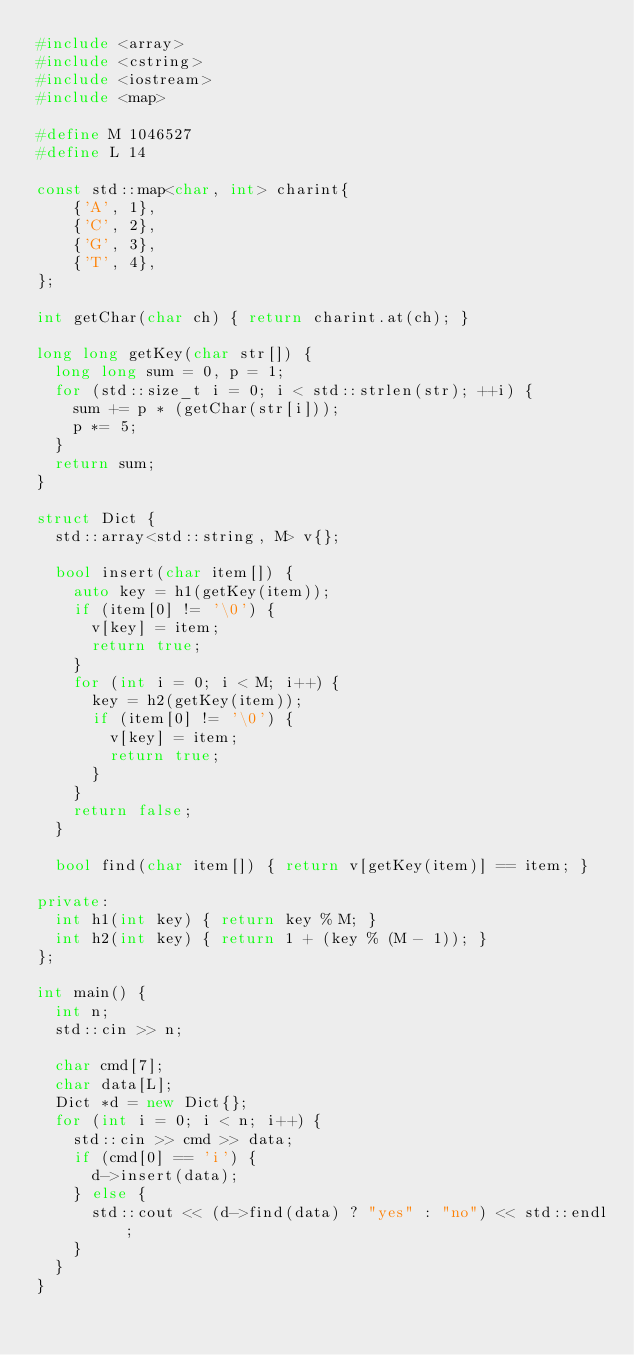<code> <loc_0><loc_0><loc_500><loc_500><_C++_>#include <array>
#include <cstring>
#include <iostream>
#include <map>

#define M 1046527
#define L 14

const std::map<char, int> charint{
    {'A', 1},
    {'C', 2},
    {'G', 3},
    {'T', 4},
};

int getChar(char ch) { return charint.at(ch); }

long long getKey(char str[]) {
  long long sum = 0, p = 1;
  for (std::size_t i = 0; i < std::strlen(str); ++i) {
    sum += p * (getChar(str[i]));
    p *= 5;
  }
  return sum;
}

struct Dict {
  std::array<std::string, M> v{};

  bool insert(char item[]) {
    auto key = h1(getKey(item));
    if (item[0] != '\0') {
      v[key] = item;
      return true;
    }
    for (int i = 0; i < M; i++) {
      key = h2(getKey(item));
      if (item[0] != '\0') {
        v[key] = item;
        return true;
      }
    }
    return false;
  }

  bool find(char item[]) { return v[getKey(item)] == item; }

private:
  int h1(int key) { return key % M; }
  int h2(int key) { return 1 + (key % (M - 1)); }
};

int main() {
  int n;
  std::cin >> n;

  char cmd[7];
  char data[L];
  Dict *d = new Dict{};
  for (int i = 0; i < n; i++) {
    std::cin >> cmd >> data;
    if (cmd[0] == 'i') {
      d->insert(data);
    } else {
      std::cout << (d->find(data) ? "yes" : "no") << std::endl;
    }
  }
}
            
</code> 